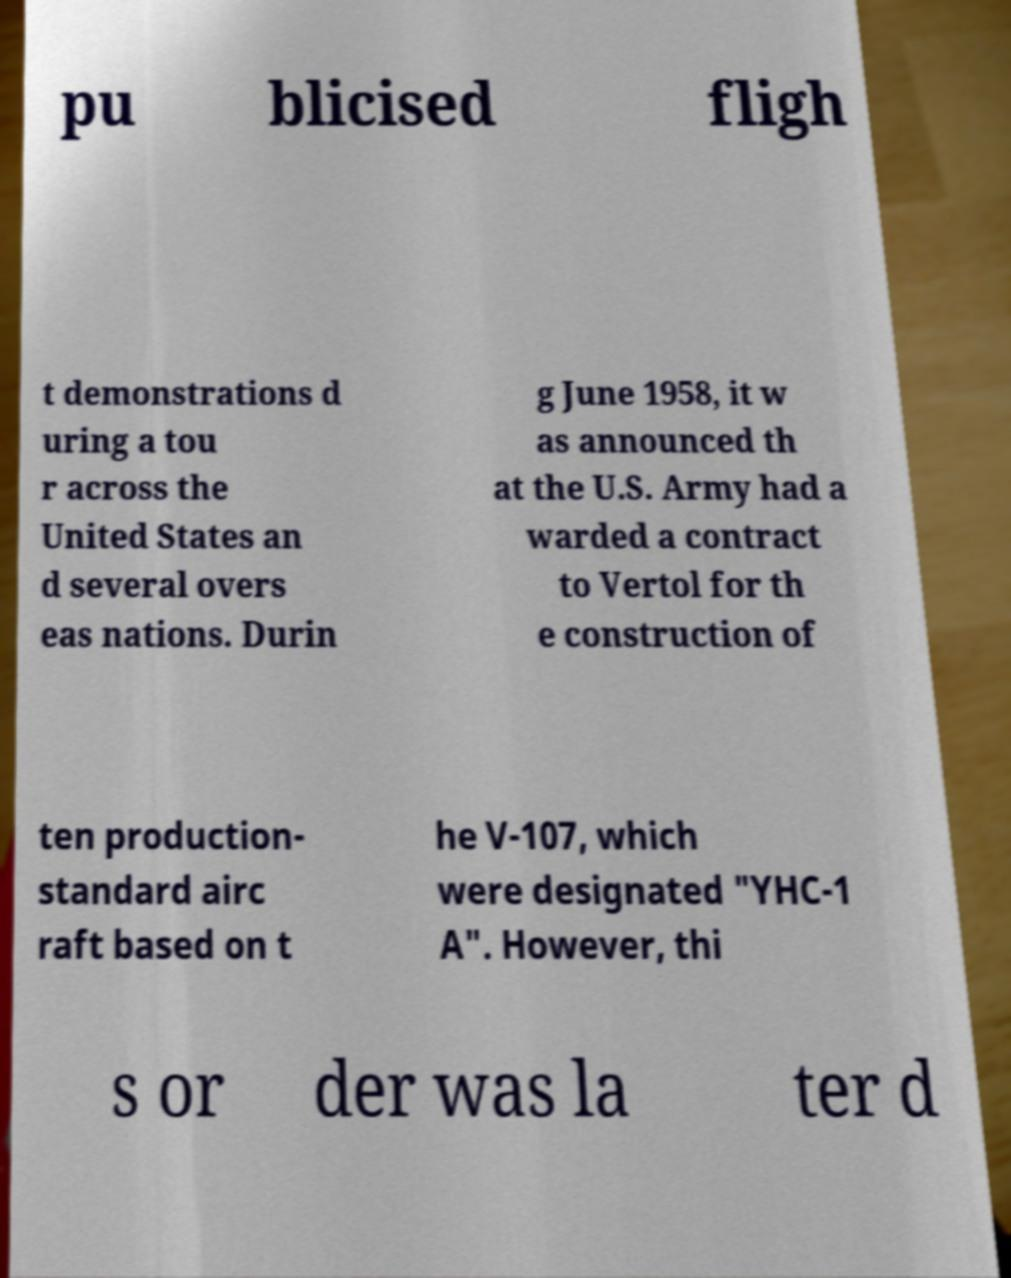For documentation purposes, I need the text within this image transcribed. Could you provide that? pu blicised fligh t demonstrations d uring a tou r across the United States an d several overs eas nations. Durin g June 1958, it w as announced th at the U.S. Army had a warded a contract to Vertol for th e construction of ten production- standard airc raft based on t he V-107, which were designated "YHC-1 A". However, thi s or der was la ter d 